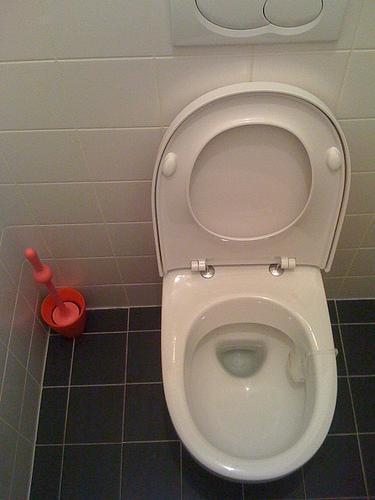How many toilets are in the picture?
Give a very brief answer. 1. How many toilets are there?
Give a very brief answer. 1. 